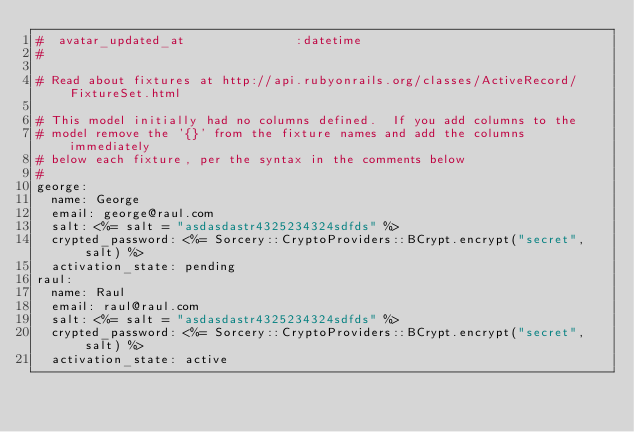<code> <loc_0><loc_0><loc_500><loc_500><_YAML_>#  avatar_updated_at               :datetime
#

# Read about fixtures at http://api.rubyonrails.org/classes/ActiveRecord/FixtureSet.html

# This model initially had no columns defined.  If you add columns to the
# model remove the '{}' from the fixture names and add the columns immediately
# below each fixture, per the syntax in the comments below
#
george:
  name: George
  email: george@raul.com
  salt: <%= salt = "asdasdastr4325234324sdfds" %>
  crypted_password: <%= Sorcery::CryptoProviders::BCrypt.encrypt("secret", salt) %>
  activation_state: pending
raul:
  name: Raul
  email: raul@raul.com
  salt: <%= salt = "asdasdastr4325234324sdfds" %>
  crypted_password: <%= Sorcery::CryptoProviders::BCrypt.encrypt("secret", salt) %>
  activation_state: active
</code> 